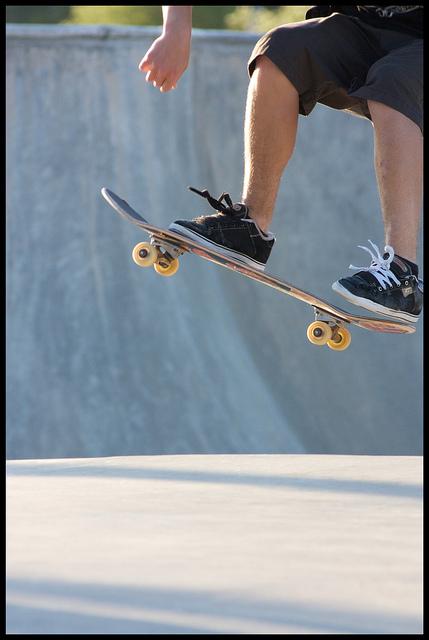What is this guy doing?
Concise answer only. Skateboarding. Is this person wearing pantyhose?
Keep it brief. No. What time of the year might we think it is?
Concise answer only. Summer. Is this a flying bird?
Answer briefly. No. What do we call the boy who's in the pic?
Short answer required. Skateboarder. 